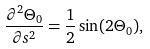Convert formula to latex. <formula><loc_0><loc_0><loc_500><loc_500>\frac { \partial ^ { 2 } \Theta _ { 0 } } { \partial s ^ { 2 } } = \frac { 1 } { 2 } \sin ( 2 \Theta _ { 0 } ) ,</formula> 